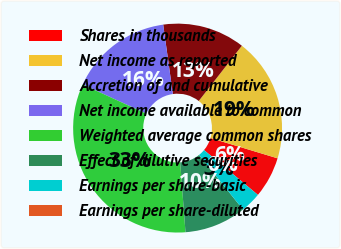<chart> <loc_0><loc_0><loc_500><loc_500><pie_chart><fcel>Shares in thousands<fcel>Net income as reported<fcel>Accretion of and cumulative<fcel>Net income available to common<fcel>Weighted average common shares<fcel>Effect of dilutive securities<fcel>Earnings per share-basic<fcel>Earnings per share-diluted<nl><fcel>6.37%<fcel>19.12%<fcel>12.75%<fcel>15.94%<fcel>33.06%<fcel>9.56%<fcel>3.19%<fcel>0.0%<nl></chart> 